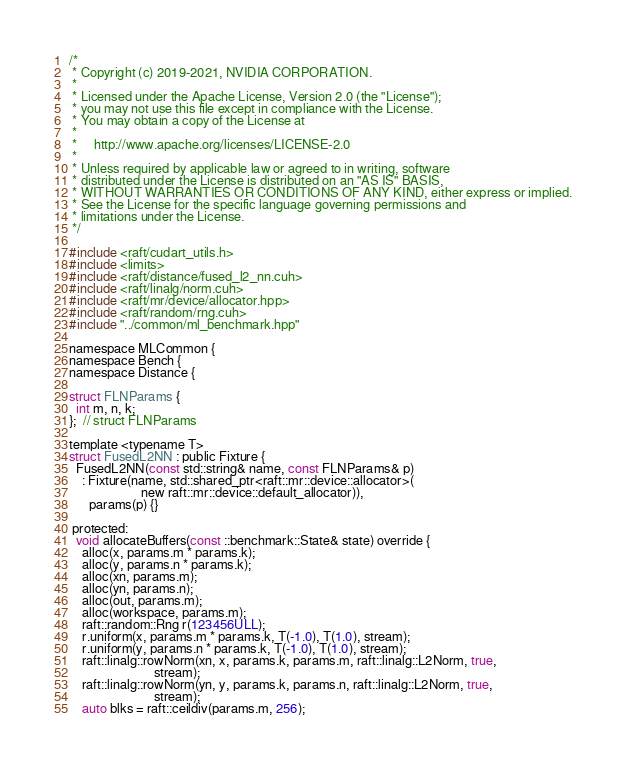<code> <loc_0><loc_0><loc_500><loc_500><_Cuda_>/*
 * Copyright (c) 2019-2021, NVIDIA CORPORATION.
 *
 * Licensed under the Apache License, Version 2.0 (the "License");
 * you may not use this file except in compliance with the License.
 * You may obtain a copy of the License at
 *
 *     http://www.apache.org/licenses/LICENSE-2.0
 *
 * Unless required by applicable law or agreed to in writing, software
 * distributed under the License is distributed on an "AS IS" BASIS,
 * WITHOUT WARRANTIES OR CONDITIONS OF ANY KIND, either express or implied.
 * See the License for the specific language governing permissions and
 * limitations under the License.
 */

#include <raft/cudart_utils.h>
#include <limits>
#include <raft/distance/fused_l2_nn.cuh>
#include <raft/linalg/norm.cuh>
#include <raft/mr/device/allocator.hpp>
#include <raft/random/rng.cuh>
#include "../common/ml_benchmark.hpp"

namespace MLCommon {
namespace Bench {
namespace Distance {

struct FLNParams {
  int m, n, k;
};  // struct FLNParams

template <typename T>
struct FusedL2NN : public Fixture {
  FusedL2NN(const std::string& name, const FLNParams& p)
    : Fixture(name, std::shared_ptr<raft::mr::device::allocator>(
                      new raft::mr::device::default_allocator)),
      params(p) {}

 protected:
  void allocateBuffers(const ::benchmark::State& state) override {
    alloc(x, params.m * params.k);
    alloc(y, params.n * params.k);
    alloc(xn, params.m);
    alloc(yn, params.n);
    alloc(out, params.m);
    alloc(workspace, params.m);
    raft::random::Rng r(123456ULL);
    r.uniform(x, params.m * params.k, T(-1.0), T(1.0), stream);
    r.uniform(y, params.n * params.k, T(-1.0), T(1.0), stream);
    raft::linalg::rowNorm(xn, x, params.k, params.m, raft::linalg::L2Norm, true,
                          stream);
    raft::linalg::rowNorm(yn, y, params.k, params.n, raft::linalg::L2Norm, true,
                          stream);
    auto blks = raft::ceildiv(params.m, 256);</code> 